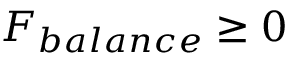<formula> <loc_0><loc_0><loc_500><loc_500>F _ { b a l a n c e } \geq 0</formula> 